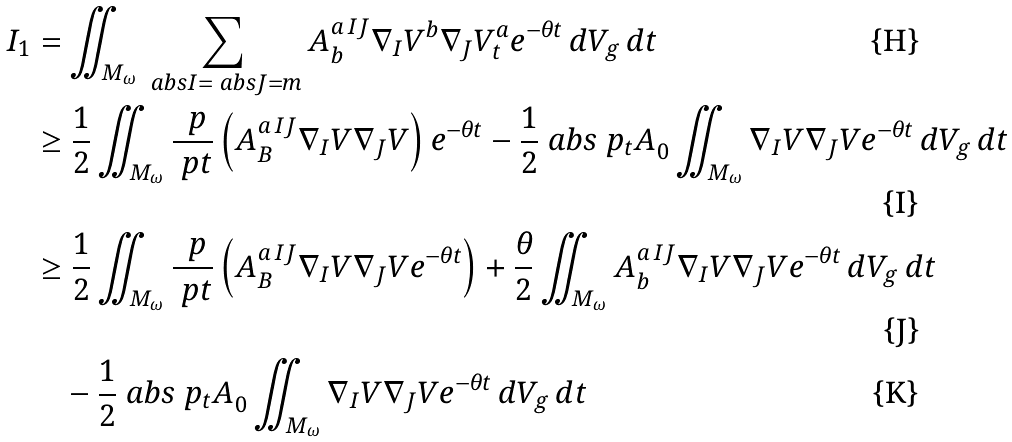<formula> <loc_0><loc_0><loc_500><loc_500>I _ { 1 } & = \iint _ { M _ { \omega } } \sum _ { \ a b s { I } = \ a b s { J } = m } A _ { b } ^ { a \, I J } \nabla _ { I } V ^ { b } \nabla _ { J } V _ { t } ^ { a } e ^ { - \theta t } \, d V _ { g } \, d t \\ & \geq \frac { 1 } { 2 } \iint _ { M _ { \omega } } \frac { \ p } { \ p t } \left ( A _ { B } ^ { a \, I J } \nabla _ { I } V \nabla _ { J } V \right ) e ^ { - \theta t } - \frac { 1 } { 2 } \ a b s { \ p _ { t } A } _ { 0 } \iint _ { M _ { \omega } } \nabla _ { I } V \nabla _ { J } V e ^ { - \theta t } \, d V _ { g } \, d t \\ & \geq \frac { 1 } { 2 } \iint _ { M _ { \omega } } \frac { \ p } { \ p t } \left ( A _ { B } ^ { a \, I J } \nabla _ { I } V \nabla _ { J } V e ^ { - \theta t } \right ) + \frac { \theta } { 2 } \iint _ { M _ { \omega } } A _ { b } ^ { a \, I J } \nabla _ { I } V \nabla _ { J } V e ^ { - \theta t } \, d V _ { g } \, d t \\ & \quad - \frac { 1 } { 2 } \ a b s { \ p _ { t } A } _ { 0 } \iint _ { M _ { \omega } } \nabla _ { I } V \nabla _ { J } V e ^ { - \theta t } \, d V _ { g } \, d t</formula> 